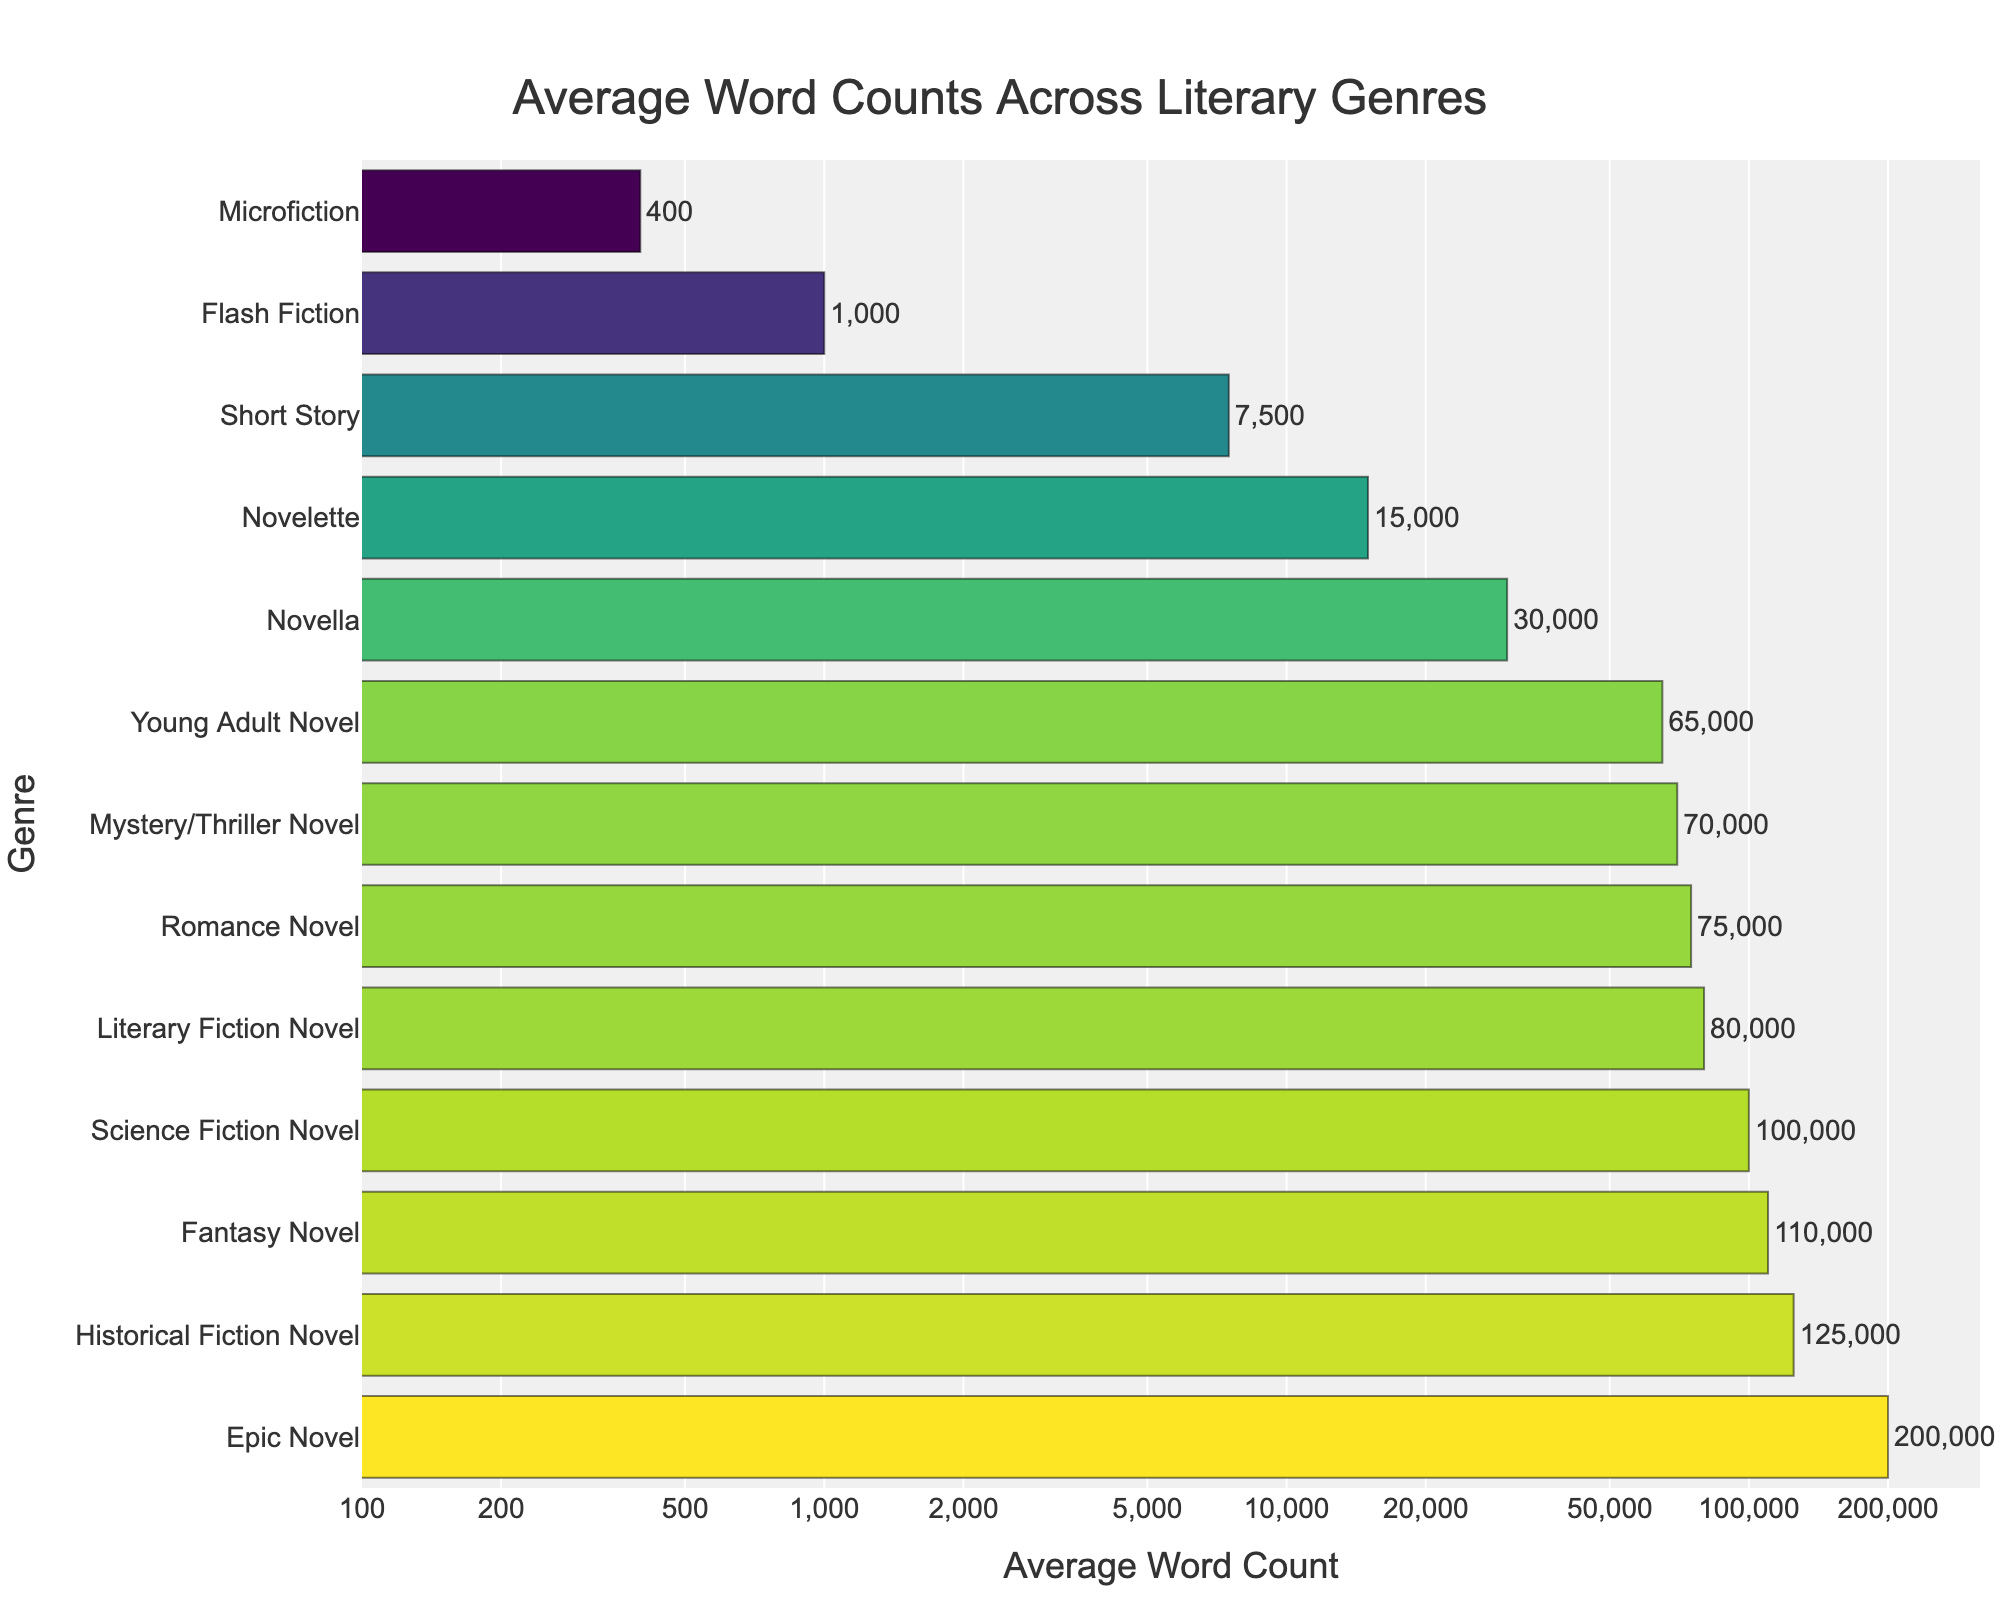Which genre has the highest average word count? The bar corresponding to "Epic Novel" is the longest, indicating the highest average word count.
Answer: Epic Novel Compare the average word count of a Fantasy Novel to a Historical Fiction Novel. Which one is greater? The bar for "Historical Fiction Novel" is longer (125,000) than the bar for "Fantasy Novel" (110,000).
Answer: Historical Fiction Novel What is the difference in average word count between a Romance Novel and a Novella? The average word count of a Romance Novel is 75,000, and for a Novella, it is 30,000. The difference is 75,000 - 30,000 = 45,000.
Answer: 45,000 Which genres have an average word count below 10,000? The bars for "Short Story" (7,500), "Flash Fiction" (1,000), and "Microfiction" (400) are shorter and below the 10,000 mark.
Answer: Short Story, Flash Fiction, Microfiction How does the average word count of a Young Adult Novel compare to a Mystery/Thriller Novel? The bar for "Young Adult Novel" is slightly shorter (65,000) than the bar for "Mystery/Thriller Novel" (70,000).
Answer: less than What is the sum of the average word counts for Microfiction, Flash Fiction, and a Short Story? The average word counts are 400 for Microfiction, 1,000 for Flash Fiction, and 7,500 for a Short Story. The sum is 400 + 1,000 + 7,500 = 8,900.
Answer: 8,900 What is the median average word count among the genres displayed? To find the median, list the word counts in ascending order: 400, 1,000, 7,500, 15,000, 30,000, 65,000, 70,000, 75,000, 80,000, 100,000, 110,000, 125,000, 200,000. The middle value or median is the 7th value in the ordered list: 70,000.
Answer: 70,000 What is the range of average word counts among all genres? The smallest value is for Microfiction (400) and the largest is for Epic Novel (200,000). The range is 200,000 - 400 = 199,600.
Answer: 199,600 